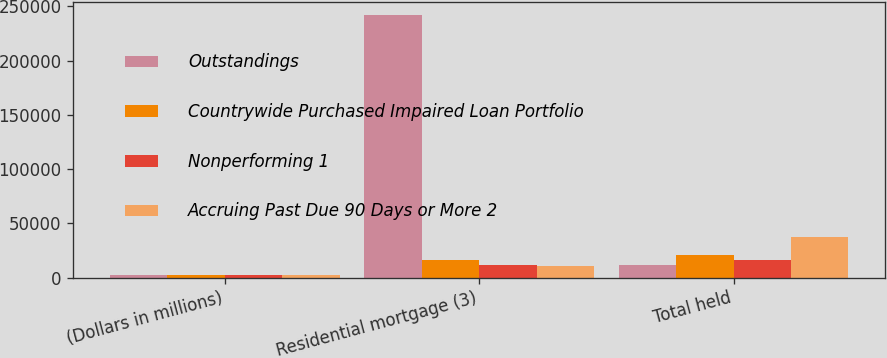Convert chart. <chart><loc_0><loc_0><loc_500><loc_500><stacked_bar_chart><ecel><fcel>(Dollars in millions)<fcel>Residential mortgage (3)<fcel>Total held<nl><fcel>Outstandings<fcel>2009<fcel>242129<fcel>11680<nl><fcel>Countrywide Purchased Impaired Loan Portfolio<fcel>2009<fcel>16596<fcel>20839<nl><fcel>Nonperforming 1<fcel>2009<fcel>11680<fcel>15829<nl><fcel>Accruing Past Due 90 Days or More 2<fcel>2009<fcel>11077<fcel>37541<nl></chart> 